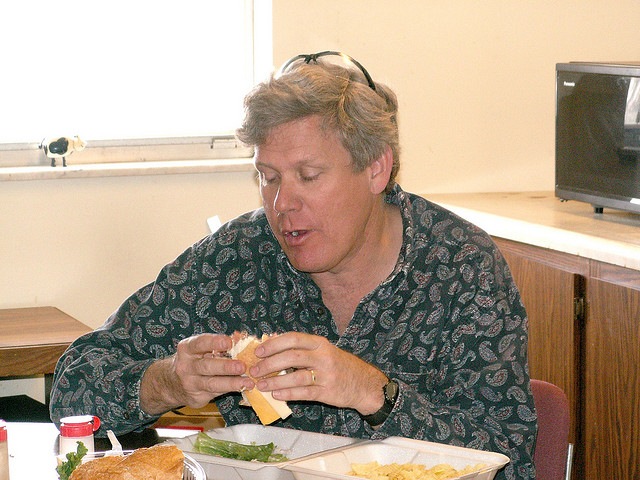<image>What kind of animal is on the window sill? I am not sure. The animal on the window sill can be a cow or a bird. What kind of animal is on the window sill? I don't know what kind of animal is on the window sill. It can be both a cow or a bird. 